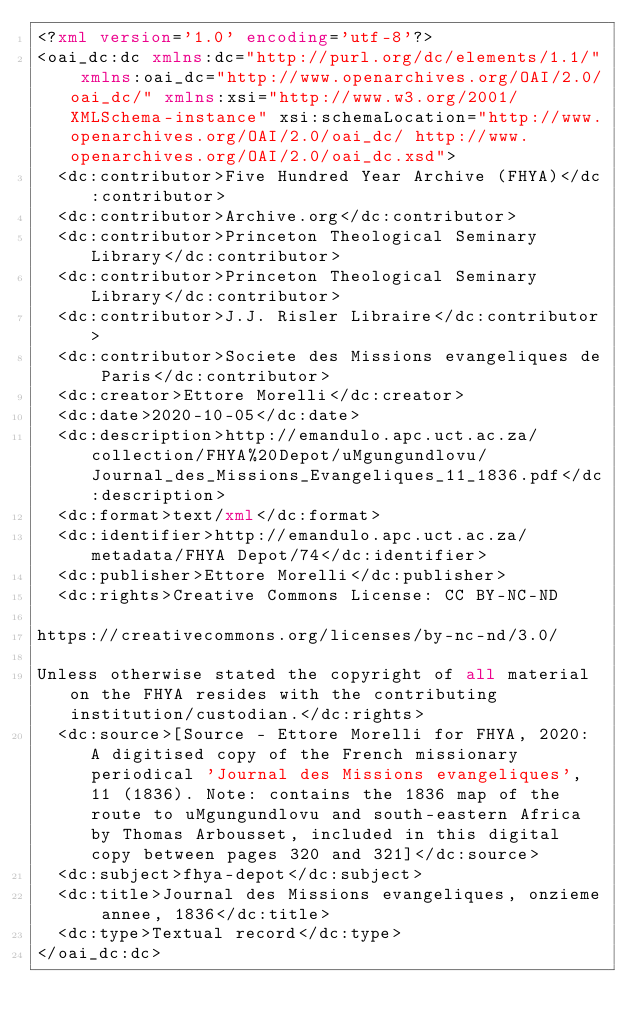Convert code to text. <code><loc_0><loc_0><loc_500><loc_500><_XML_><?xml version='1.0' encoding='utf-8'?>
<oai_dc:dc xmlns:dc="http://purl.org/dc/elements/1.1/" xmlns:oai_dc="http://www.openarchives.org/OAI/2.0/oai_dc/" xmlns:xsi="http://www.w3.org/2001/XMLSchema-instance" xsi:schemaLocation="http://www.openarchives.org/OAI/2.0/oai_dc/ http://www.openarchives.org/OAI/2.0/oai_dc.xsd">
  <dc:contributor>Five Hundred Year Archive (FHYA)</dc:contributor>
  <dc:contributor>Archive.org</dc:contributor>
  <dc:contributor>Princeton Theological Seminary Library</dc:contributor>
  <dc:contributor>Princeton Theological Seminary Library</dc:contributor>
  <dc:contributor>J.J. Risler Libraire</dc:contributor>
  <dc:contributor>Societe des Missions evangeliques de Paris</dc:contributor>
  <dc:creator>Ettore Morelli</dc:creator>
  <dc:date>2020-10-05</dc:date>
  <dc:description>http://emandulo.apc.uct.ac.za/collection/FHYA%20Depot/uMgungundlovu/Journal_des_Missions_Evangeliques_11_1836.pdf</dc:description>
  <dc:format>text/xml</dc:format>
  <dc:identifier>http://emandulo.apc.uct.ac.za/metadata/FHYA Depot/74</dc:identifier>
  <dc:publisher>Ettore Morelli</dc:publisher>
  <dc:rights>Creative Commons License: CC BY-NC-ND  

https://creativecommons.org/licenses/by-nc-nd/3.0/

Unless otherwise stated the copyright of all material on the FHYA resides with the contributing institution/custodian.</dc:rights>
  <dc:source>[Source - Ettore Morelli for FHYA, 2020: A digitised copy of the French missionary periodical 'Journal des Missions evangeliques', 11 (1836). Note: contains the 1836 map of the route to uMgungundlovu and south-eastern Africa by Thomas Arbousset, included in this digital copy between pages 320 and 321]</dc:source>
  <dc:subject>fhya-depot</dc:subject>
  <dc:title>Journal des Missions evangeliques, onzieme annee, 1836</dc:title>
  <dc:type>Textual record</dc:type>
</oai_dc:dc>
</code> 